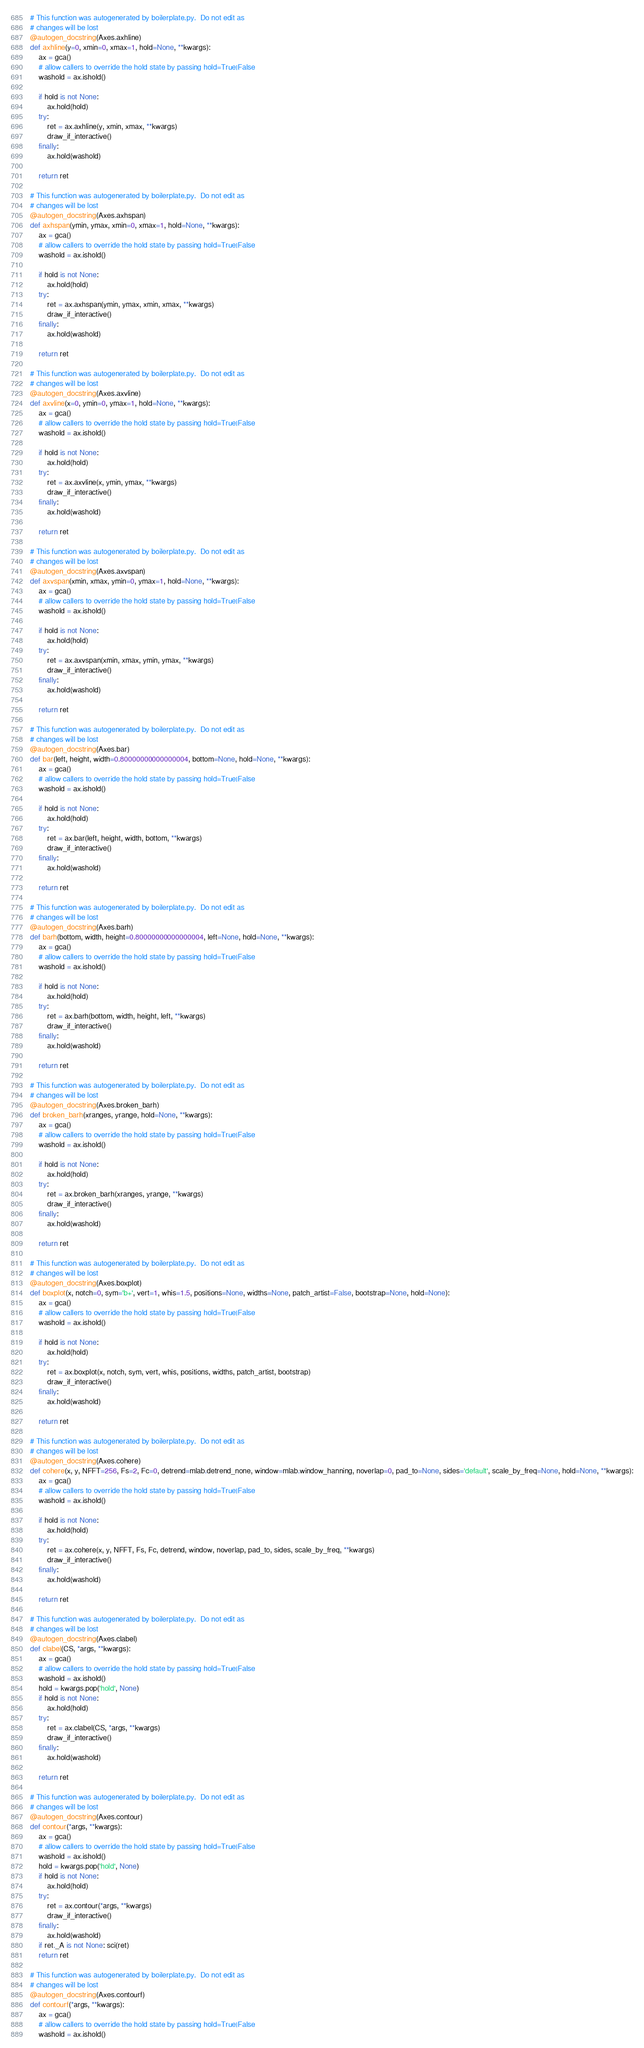Convert code to text. <code><loc_0><loc_0><loc_500><loc_500><_Python_># This function was autogenerated by boilerplate.py.  Do not edit as
# changes will be lost
@autogen_docstring(Axes.axhline)
def axhline(y=0, xmin=0, xmax=1, hold=None, **kwargs):
    ax = gca()
    # allow callers to override the hold state by passing hold=True|False
    washold = ax.ishold()

    if hold is not None:
        ax.hold(hold)
    try:
        ret = ax.axhline(y, xmin, xmax, **kwargs)
        draw_if_interactive()
    finally:
        ax.hold(washold)

    return ret

# This function was autogenerated by boilerplate.py.  Do not edit as
# changes will be lost
@autogen_docstring(Axes.axhspan)
def axhspan(ymin, ymax, xmin=0, xmax=1, hold=None, **kwargs):
    ax = gca()
    # allow callers to override the hold state by passing hold=True|False
    washold = ax.ishold()

    if hold is not None:
        ax.hold(hold)
    try:
        ret = ax.axhspan(ymin, ymax, xmin, xmax, **kwargs)
        draw_if_interactive()
    finally:
        ax.hold(washold)

    return ret

# This function was autogenerated by boilerplate.py.  Do not edit as
# changes will be lost
@autogen_docstring(Axes.axvline)
def axvline(x=0, ymin=0, ymax=1, hold=None, **kwargs):
    ax = gca()
    # allow callers to override the hold state by passing hold=True|False
    washold = ax.ishold()

    if hold is not None:
        ax.hold(hold)
    try:
        ret = ax.axvline(x, ymin, ymax, **kwargs)
        draw_if_interactive()
    finally:
        ax.hold(washold)

    return ret

# This function was autogenerated by boilerplate.py.  Do not edit as
# changes will be lost
@autogen_docstring(Axes.axvspan)
def axvspan(xmin, xmax, ymin=0, ymax=1, hold=None, **kwargs):
    ax = gca()
    # allow callers to override the hold state by passing hold=True|False
    washold = ax.ishold()

    if hold is not None:
        ax.hold(hold)
    try:
        ret = ax.axvspan(xmin, xmax, ymin, ymax, **kwargs)
        draw_if_interactive()
    finally:
        ax.hold(washold)

    return ret

# This function was autogenerated by boilerplate.py.  Do not edit as
# changes will be lost
@autogen_docstring(Axes.bar)
def bar(left, height, width=0.80000000000000004, bottom=None, hold=None, **kwargs):
    ax = gca()
    # allow callers to override the hold state by passing hold=True|False
    washold = ax.ishold()

    if hold is not None:
        ax.hold(hold)
    try:
        ret = ax.bar(left, height, width, bottom, **kwargs)
        draw_if_interactive()
    finally:
        ax.hold(washold)

    return ret

# This function was autogenerated by boilerplate.py.  Do not edit as
# changes will be lost
@autogen_docstring(Axes.barh)
def barh(bottom, width, height=0.80000000000000004, left=None, hold=None, **kwargs):
    ax = gca()
    # allow callers to override the hold state by passing hold=True|False
    washold = ax.ishold()

    if hold is not None:
        ax.hold(hold)
    try:
        ret = ax.barh(bottom, width, height, left, **kwargs)
        draw_if_interactive()
    finally:
        ax.hold(washold)

    return ret

# This function was autogenerated by boilerplate.py.  Do not edit as
# changes will be lost
@autogen_docstring(Axes.broken_barh)
def broken_barh(xranges, yrange, hold=None, **kwargs):
    ax = gca()
    # allow callers to override the hold state by passing hold=True|False
    washold = ax.ishold()

    if hold is not None:
        ax.hold(hold)
    try:
        ret = ax.broken_barh(xranges, yrange, **kwargs)
        draw_if_interactive()
    finally:
        ax.hold(washold)

    return ret

# This function was autogenerated by boilerplate.py.  Do not edit as
# changes will be lost
@autogen_docstring(Axes.boxplot)
def boxplot(x, notch=0, sym='b+', vert=1, whis=1.5, positions=None, widths=None, patch_artist=False, bootstrap=None, hold=None):
    ax = gca()
    # allow callers to override the hold state by passing hold=True|False
    washold = ax.ishold()

    if hold is not None:
        ax.hold(hold)
    try:
        ret = ax.boxplot(x, notch, sym, vert, whis, positions, widths, patch_artist, bootstrap)
        draw_if_interactive()
    finally:
        ax.hold(washold)

    return ret

# This function was autogenerated by boilerplate.py.  Do not edit as
# changes will be lost
@autogen_docstring(Axes.cohere)
def cohere(x, y, NFFT=256, Fs=2, Fc=0, detrend=mlab.detrend_none, window=mlab.window_hanning, noverlap=0, pad_to=None, sides='default', scale_by_freq=None, hold=None, **kwargs):
    ax = gca()
    # allow callers to override the hold state by passing hold=True|False
    washold = ax.ishold()

    if hold is not None:
        ax.hold(hold)
    try:
        ret = ax.cohere(x, y, NFFT, Fs, Fc, detrend, window, noverlap, pad_to, sides, scale_by_freq, **kwargs)
        draw_if_interactive()
    finally:
        ax.hold(washold)

    return ret

# This function was autogenerated by boilerplate.py.  Do not edit as
# changes will be lost
@autogen_docstring(Axes.clabel)
def clabel(CS, *args, **kwargs):
    ax = gca()
    # allow callers to override the hold state by passing hold=True|False
    washold = ax.ishold()
    hold = kwargs.pop('hold', None)
    if hold is not None:
        ax.hold(hold)
    try:
        ret = ax.clabel(CS, *args, **kwargs)
        draw_if_interactive()
    finally:
        ax.hold(washold)

    return ret

# This function was autogenerated by boilerplate.py.  Do not edit as
# changes will be lost
@autogen_docstring(Axes.contour)
def contour(*args, **kwargs):
    ax = gca()
    # allow callers to override the hold state by passing hold=True|False
    washold = ax.ishold()
    hold = kwargs.pop('hold', None)
    if hold is not None:
        ax.hold(hold)
    try:
        ret = ax.contour(*args, **kwargs)
        draw_if_interactive()
    finally:
        ax.hold(washold)
    if ret._A is not None: sci(ret)
    return ret

# This function was autogenerated by boilerplate.py.  Do not edit as
# changes will be lost
@autogen_docstring(Axes.contourf)
def contourf(*args, **kwargs):
    ax = gca()
    # allow callers to override the hold state by passing hold=True|False
    washold = ax.ishold()</code> 